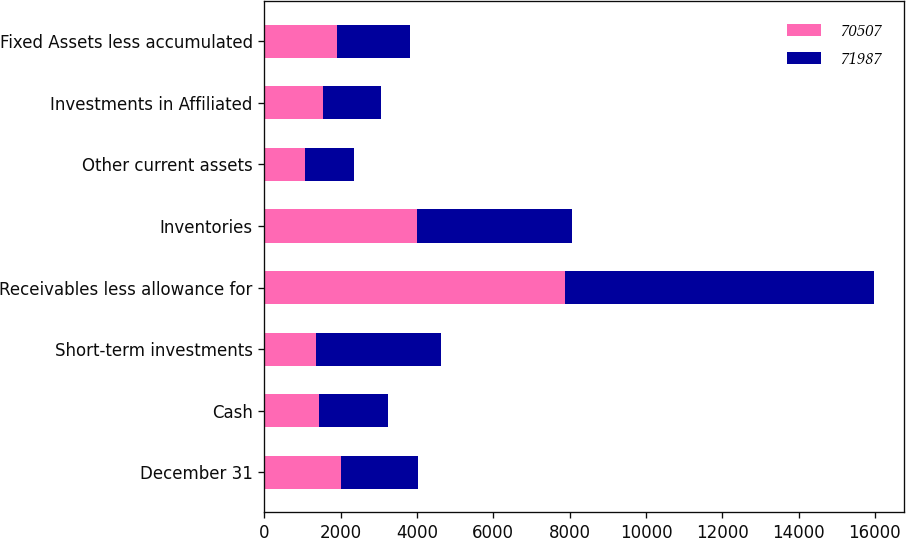Convert chart. <chart><loc_0><loc_0><loc_500><loc_500><stacked_bar_chart><ecel><fcel>December 31<fcel>Cash<fcel>Short-term investments<fcel>Receivables less allowance for<fcel>Inventories<fcel>Other current assets<fcel>Investments in Affiliated<fcel>Fixed Assets less accumulated<nl><fcel>70507<fcel>2018<fcel>1433<fcel>1344<fcel>7881<fcel>4010<fcel>1063<fcel>1538<fcel>1908<nl><fcel>71987<fcel>2017<fcel>1799<fcel>3290<fcel>8084<fcel>4046<fcel>1278<fcel>1519<fcel>1908<nl></chart> 